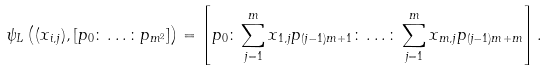Convert formula to latex. <formula><loc_0><loc_0><loc_500><loc_500>\psi _ { L } \left ( ( x _ { i , j } ) , [ p _ { 0 } \colon \dots \colon p _ { m ^ { 2 } } ] \right ) = \left [ p _ { 0 } \colon \sum _ { j = 1 } ^ { m } x _ { 1 , j } p _ { ( j - 1 ) m + 1 } \colon \dots \colon \sum _ { j = 1 } ^ { m } x _ { m , j } p _ { ( j - 1 ) m + m } \right ] .</formula> 